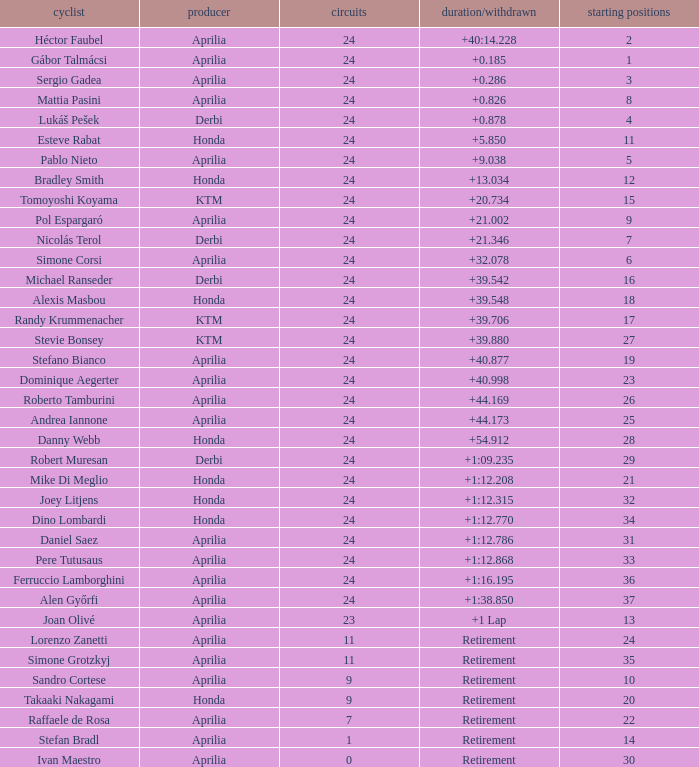What is the time with 10 grids? Retirement. 